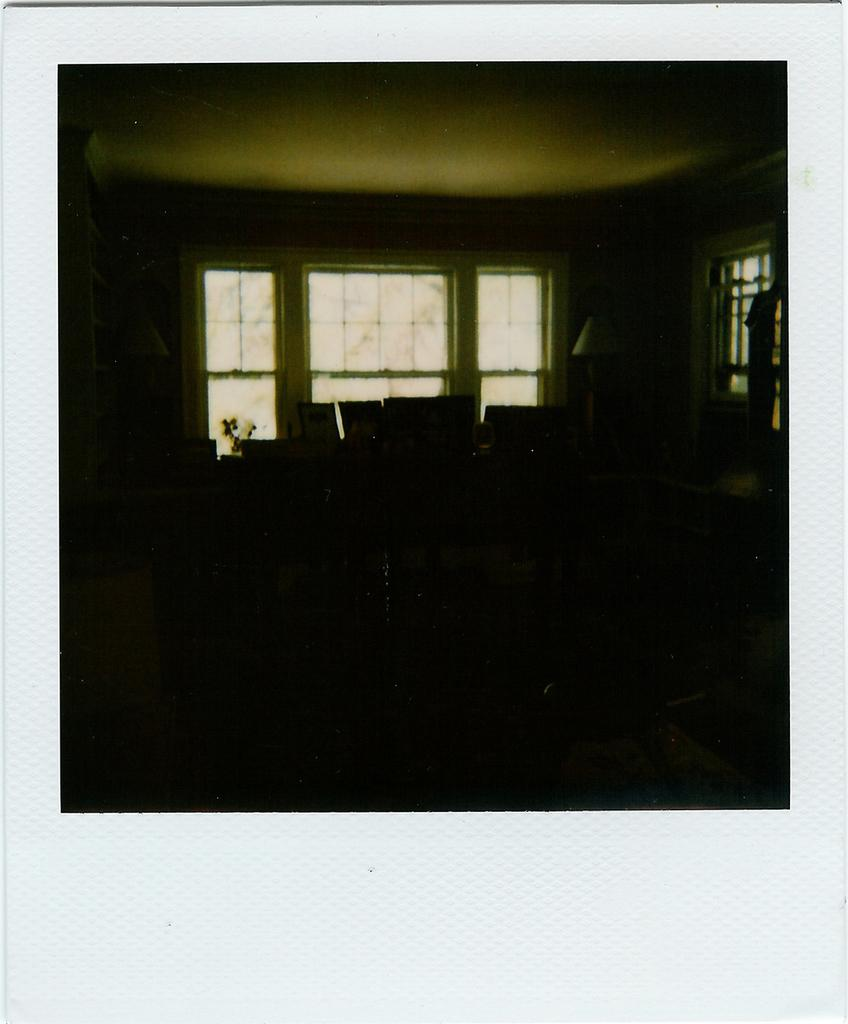What type of location is depicted in the image? The image shows the inside of a building. Can you describe the lighting conditions in the image? The interior of the building is dark. Are there any visual elements surrounding the image? Yes, the image has borders. What type of bait is being used to catch fish in the image? There is no indication of fishing or bait in the image, as it shows the inside of a building. What tax rate applies to the items in the image? There is no information about taxes or items in the image, as it only shows the interior of a building. 